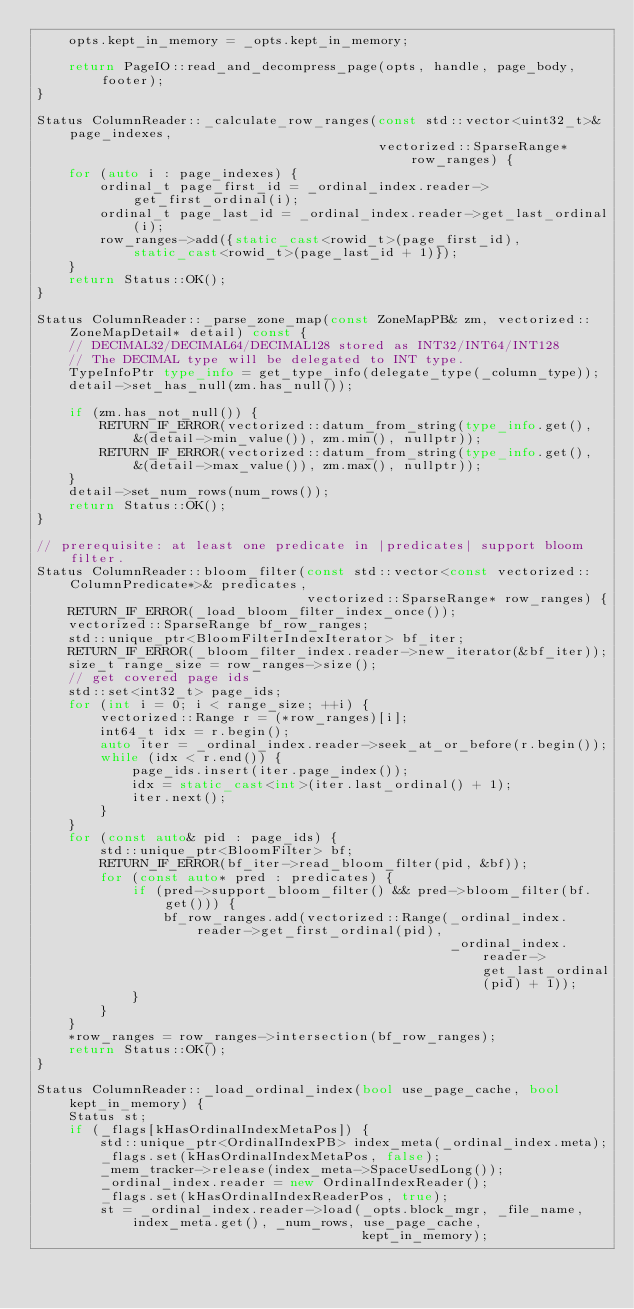Convert code to text. <code><loc_0><loc_0><loc_500><loc_500><_C++_>    opts.kept_in_memory = _opts.kept_in_memory;

    return PageIO::read_and_decompress_page(opts, handle, page_body, footer);
}

Status ColumnReader::_calculate_row_ranges(const std::vector<uint32_t>& page_indexes,
                                           vectorized::SparseRange* row_ranges) {
    for (auto i : page_indexes) {
        ordinal_t page_first_id = _ordinal_index.reader->get_first_ordinal(i);
        ordinal_t page_last_id = _ordinal_index.reader->get_last_ordinal(i);
        row_ranges->add({static_cast<rowid_t>(page_first_id), static_cast<rowid_t>(page_last_id + 1)});
    }
    return Status::OK();
}

Status ColumnReader::_parse_zone_map(const ZoneMapPB& zm, vectorized::ZoneMapDetail* detail) const {
    // DECIMAL32/DECIMAL64/DECIMAL128 stored as INT32/INT64/INT128
    // The DECIMAL type will be delegated to INT type.
    TypeInfoPtr type_info = get_type_info(delegate_type(_column_type));
    detail->set_has_null(zm.has_null());

    if (zm.has_not_null()) {
        RETURN_IF_ERROR(vectorized::datum_from_string(type_info.get(), &(detail->min_value()), zm.min(), nullptr));
        RETURN_IF_ERROR(vectorized::datum_from_string(type_info.get(), &(detail->max_value()), zm.max(), nullptr));
    }
    detail->set_num_rows(num_rows());
    return Status::OK();
}

// prerequisite: at least one predicate in |predicates| support bloom filter.
Status ColumnReader::bloom_filter(const std::vector<const vectorized::ColumnPredicate*>& predicates,
                                  vectorized::SparseRange* row_ranges) {
    RETURN_IF_ERROR(_load_bloom_filter_index_once());
    vectorized::SparseRange bf_row_ranges;
    std::unique_ptr<BloomFilterIndexIterator> bf_iter;
    RETURN_IF_ERROR(_bloom_filter_index.reader->new_iterator(&bf_iter));
    size_t range_size = row_ranges->size();
    // get covered page ids
    std::set<int32_t> page_ids;
    for (int i = 0; i < range_size; ++i) {
        vectorized::Range r = (*row_ranges)[i];
        int64_t idx = r.begin();
        auto iter = _ordinal_index.reader->seek_at_or_before(r.begin());
        while (idx < r.end()) {
            page_ids.insert(iter.page_index());
            idx = static_cast<int>(iter.last_ordinal() + 1);
            iter.next();
        }
    }
    for (const auto& pid : page_ids) {
        std::unique_ptr<BloomFilter> bf;
        RETURN_IF_ERROR(bf_iter->read_bloom_filter(pid, &bf));
        for (const auto* pred : predicates) {
            if (pred->support_bloom_filter() && pred->bloom_filter(bf.get())) {
                bf_row_ranges.add(vectorized::Range(_ordinal_index.reader->get_first_ordinal(pid),
                                                    _ordinal_index.reader->get_last_ordinal(pid) + 1));
            }
        }
    }
    *row_ranges = row_ranges->intersection(bf_row_ranges);
    return Status::OK();
}

Status ColumnReader::_load_ordinal_index(bool use_page_cache, bool kept_in_memory) {
    Status st;
    if (_flags[kHasOrdinalIndexMetaPos]) {
        std::unique_ptr<OrdinalIndexPB> index_meta(_ordinal_index.meta);
        _flags.set(kHasOrdinalIndexMetaPos, false);
        _mem_tracker->release(index_meta->SpaceUsedLong());
        _ordinal_index.reader = new OrdinalIndexReader();
        _flags.set(kHasOrdinalIndexReaderPos, true);
        st = _ordinal_index.reader->load(_opts.block_mgr, _file_name, index_meta.get(), _num_rows, use_page_cache,
                                         kept_in_memory);</code> 